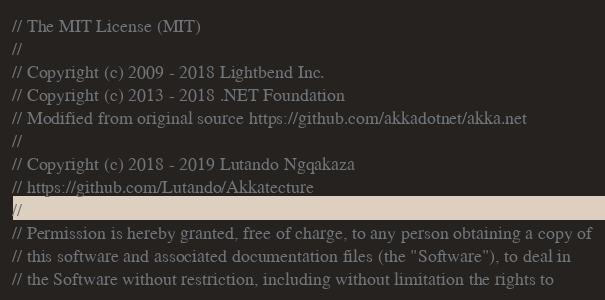<code> <loc_0><loc_0><loc_500><loc_500><_C#_>// The MIT License (MIT)
//
// Copyright (c) 2009 - 2018 Lightbend Inc.
// Copyright (c) 2013 - 2018 .NET Foundation
// Modified from original source https://github.com/akkadotnet/akka.net
//
// Copyright (c) 2018 - 2019 Lutando Ngqakaza
// https://github.com/Lutando/Akkatecture 
// 
// Permission is hereby granted, free of charge, to any person obtaining a copy of
// this software and associated documentation files (the "Software"), to deal in
// the Software without restriction, including without limitation the rights to</code> 